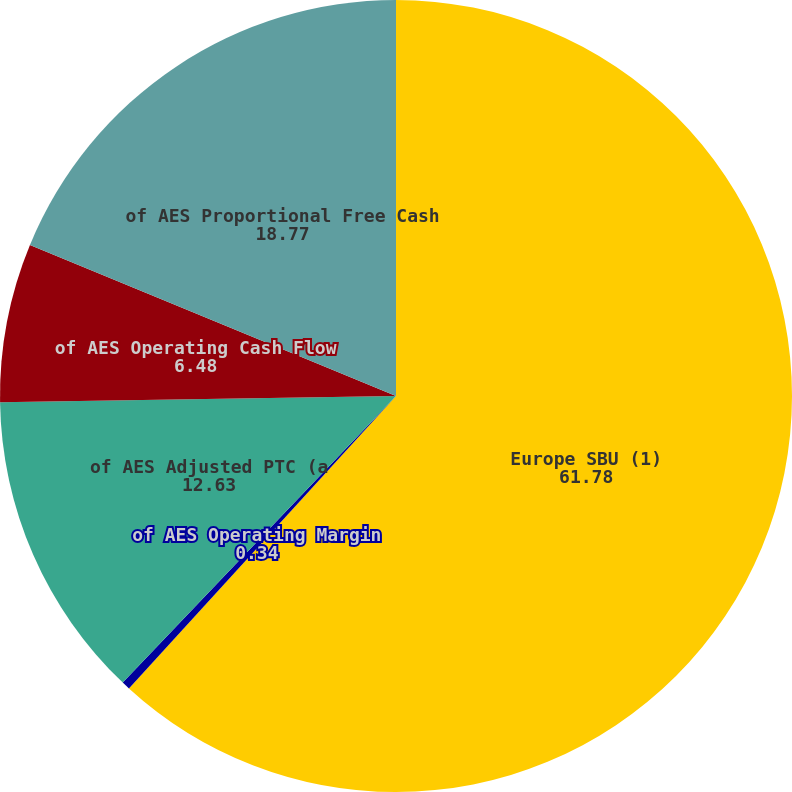Convert chart to OTSL. <chart><loc_0><loc_0><loc_500><loc_500><pie_chart><fcel>Europe SBU (1)<fcel>of AES Operating Margin<fcel>of AES Adjusted PTC (a<fcel>of AES Operating Cash Flow<fcel>of AES Proportional Free Cash<nl><fcel>61.78%<fcel>0.34%<fcel>12.63%<fcel>6.48%<fcel>18.77%<nl></chart> 